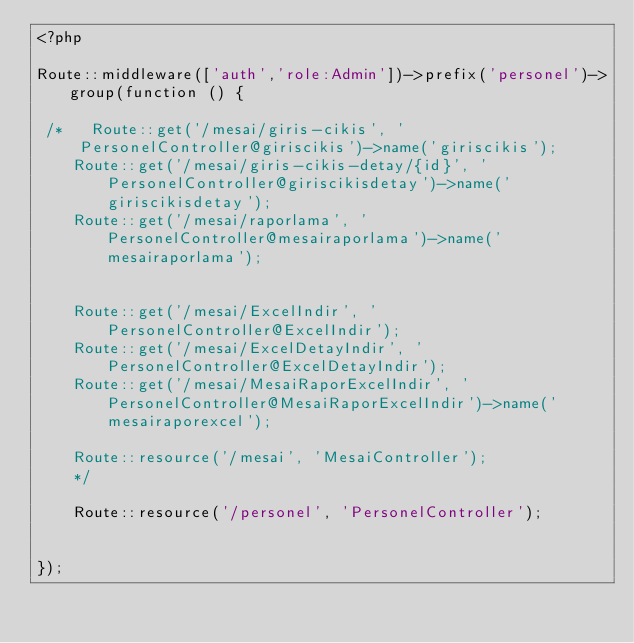Convert code to text. <code><loc_0><loc_0><loc_500><loc_500><_PHP_><?php

Route::middleware(['auth','role:Admin'])->prefix('personel')->group(function () {

 /*   Route::get('/mesai/giris-cikis', 'PersonelController@giriscikis')->name('giriscikis');
    Route::get('/mesai/giris-cikis-detay/{id}', 'PersonelController@giriscikisdetay')->name('giriscikisdetay');
    Route::get('/mesai/raporlama', 'PersonelController@mesairaporlama')->name('mesairaporlama');


    Route::get('/mesai/ExcelIndir', 'PersonelController@ExcelIndir');
    Route::get('/mesai/ExcelDetayIndir', 'PersonelController@ExcelDetayIndir');
    Route::get('/mesai/MesaiRaporExcelIndir', 'PersonelController@MesaiRaporExcelIndir')->name('mesairaporexcel');

    Route::resource('/mesai', 'MesaiController');
    */

    Route::resource('/personel', 'PersonelController');


});
</code> 